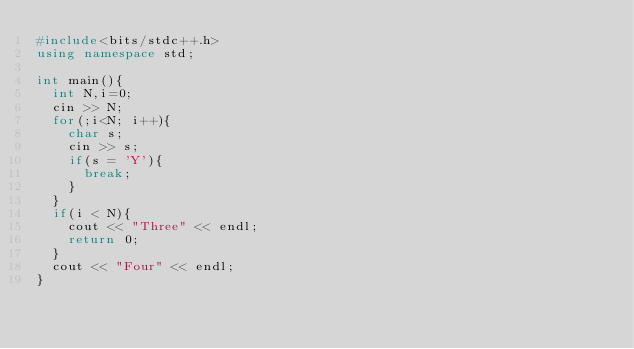Convert code to text. <code><loc_0><loc_0><loc_500><loc_500><_C++_>#include<bits/stdc++.h>
using namespace std;

int main(){
  int N,i=0;
  cin >> N;
  for(;i<N; i++){
    char s;
    cin >> s;
    if(s = 'Y'){
      break;
    }
  }
  if(i < N){
    cout << "Three" << endl;
    return 0;
  }
  cout << "Four" << endl;
} 
</code> 